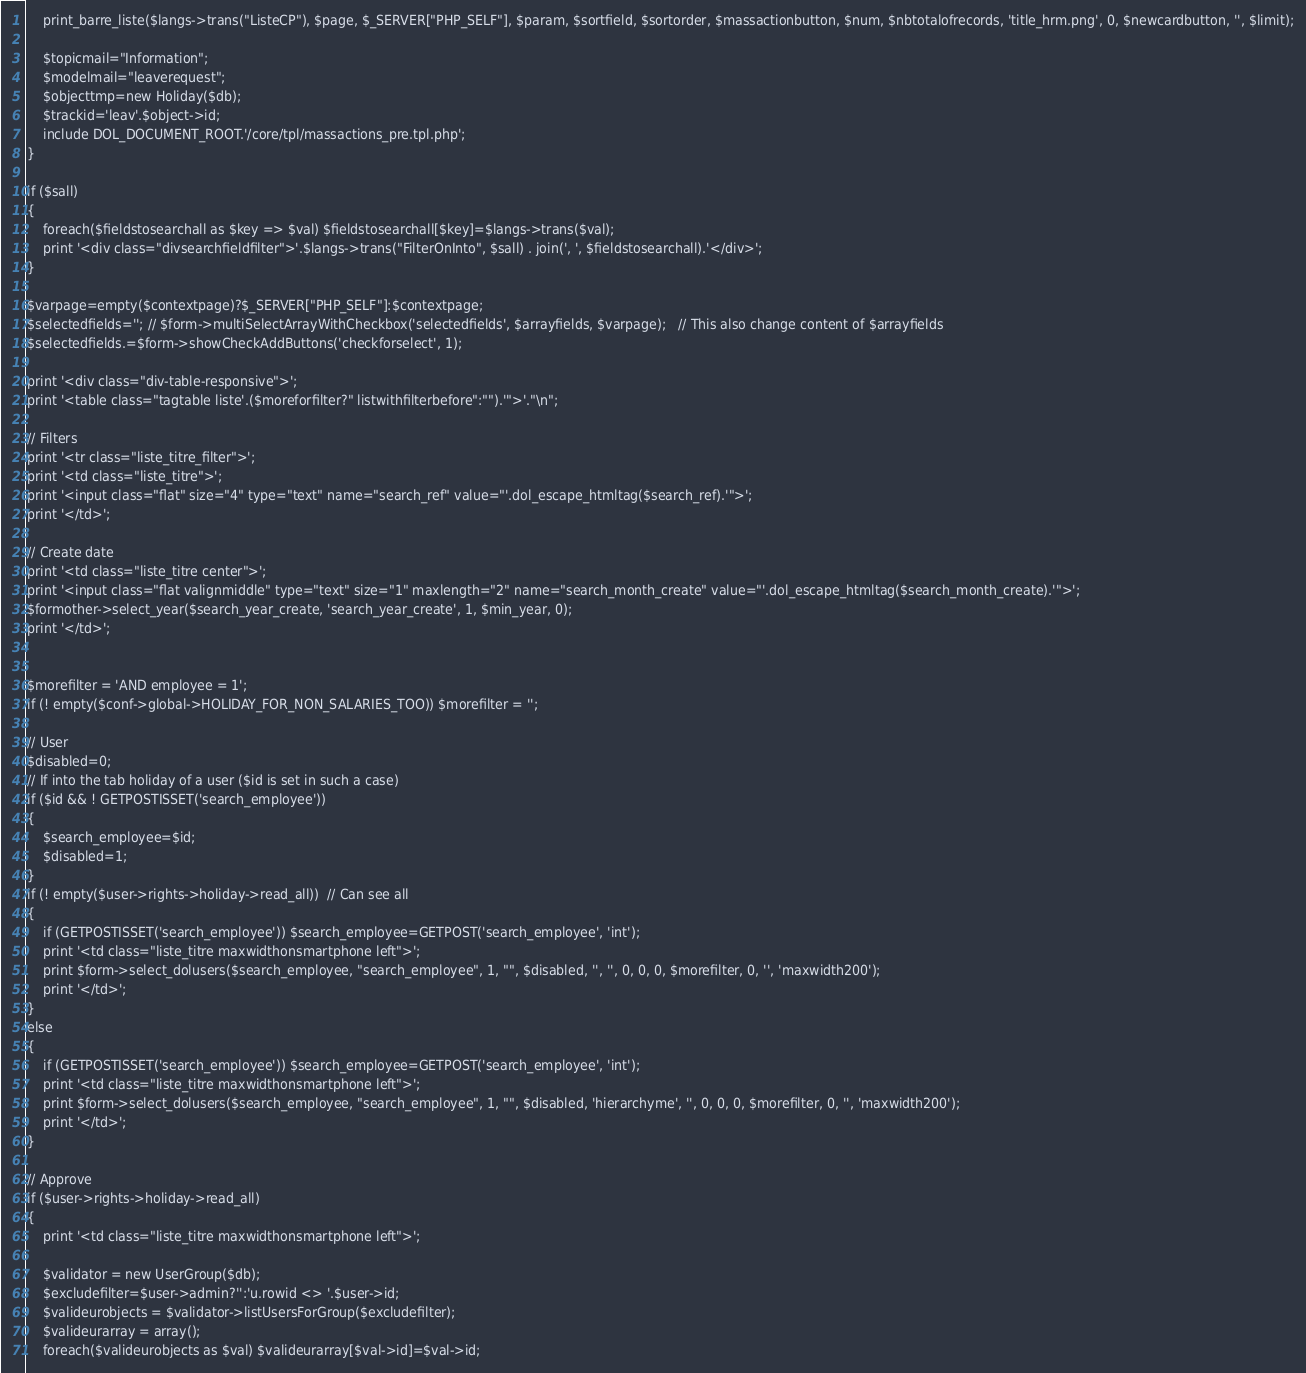Convert code to text. <code><loc_0><loc_0><loc_500><loc_500><_PHP_>
	print_barre_liste($langs->trans("ListeCP"), $page, $_SERVER["PHP_SELF"], $param, $sortfield, $sortorder, $massactionbutton, $num, $nbtotalofrecords, 'title_hrm.png', 0, $newcardbutton, '', $limit);

	$topicmail="Information";
	$modelmail="leaverequest";
	$objecttmp=new Holiday($db);
	$trackid='leav'.$object->id;
	include DOL_DOCUMENT_ROOT.'/core/tpl/massactions_pre.tpl.php';
}

if ($sall)
{
    foreach($fieldstosearchall as $key => $val) $fieldstosearchall[$key]=$langs->trans($val);
    print '<div class="divsearchfieldfilter">'.$langs->trans("FilterOnInto", $sall) . join(', ', $fieldstosearchall).'</div>';
}

$varpage=empty($contextpage)?$_SERVER["PHP_SELF"]:$contextpage;
$selectedfields='';	// $form->multiSelectArrayWithCheckbox('selectedfields', $arrayfields, $varpage);	// This also change content of $arrayfields
$selectedfields.=$form->showCheckAddButtons('checkforselect', 1);

print '<div class="div-table-responsive">';
print '<table class="tagtable liste'.($moreforfilter?" listwithfilterbefore":"").'">'."\n";

// Filters
print '<tr class="liste_titre_filter">';
print '<td class="liste_titre">';
print '<input class="flat" size="4" type="text" name="search_ref" value="'.dol_escape_htmltag($search_ref).'">';
print '</td>';

// Create date
print '<td class="liste_titre center">';
print '<input class="flat valignmiddle" type="text" size="1" maxlength="2" name="search_month_create" value="'.dol_escape_htmltag($search_month_create).'">';
$formother->select_year($search_year_create, 'search_year_create', 1, $min_year, 0);
print '</td>';


$morefilter = 'AND employee = 1';
if (! empty($conf->global->HOLIDAY_FOR_NON_SALARIES_TOO)) $morefilter = '';

// User
$disabled=0;
// If into the tab holiday of a user ($id is set in such a case)
if ($id && ! GETPOSTISSET('search_employee'))
{
	$search_employee=$id;
	$disabled=1;
}
if (! empty($user->rights->holiday->read_all))	// Can see all
{
	if (GETPOSTISSET('search_employee')) $search_employee=GETPOST('search_employee', 'int');
	print '<td class="liste_titre maxwidthonsmartphone left">';
	print $form->select_dolusers($search_employee, "search_employee", 1, "", $disabled, '', '', 0, 0, 0, $morefilter, 0, '', 'maxwidth200');
    print '</td>';
}
else
{
	if (GETPOSTISSET('search_employee')) $search_employee=GETPOST('search_employee', 'int');
    print '<td class="liste_titre maxwidthonsmartphone left">';
    print $form->select_dolusers($search_employee, "search_employee", 1, "", $disabled, 'hierarchyme', '', 0, 0, 0, $morefilter, 0, '', 'maxwidth200');
    print '</td>';
}

// Approve
if ($user->rights->holiday->read_all)
{
    print '<td class="liste_titre maxwidthonsmartphone left">';

    $validator = new UserGroup($db);
    $excludefilter=$user->admin?'':'u.rowid <> '.$user->id;
    $valideurobjects = $validator->listUsersForGroup($excludefilter);
    $valideurarray = array();
    foreach($valideurobjects as $val) $valideurarray[$val->id]=$val->id;</code> 